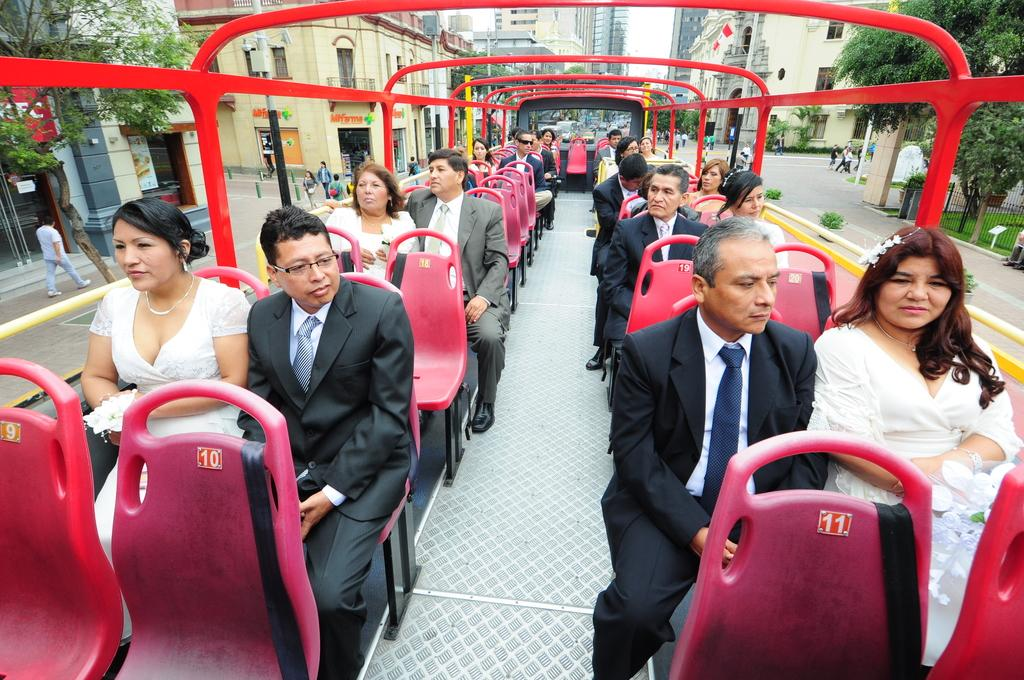<image>
Render a clear and concise summary of the photo. A man in a black suit sits behind a red seat labelled number 10. 